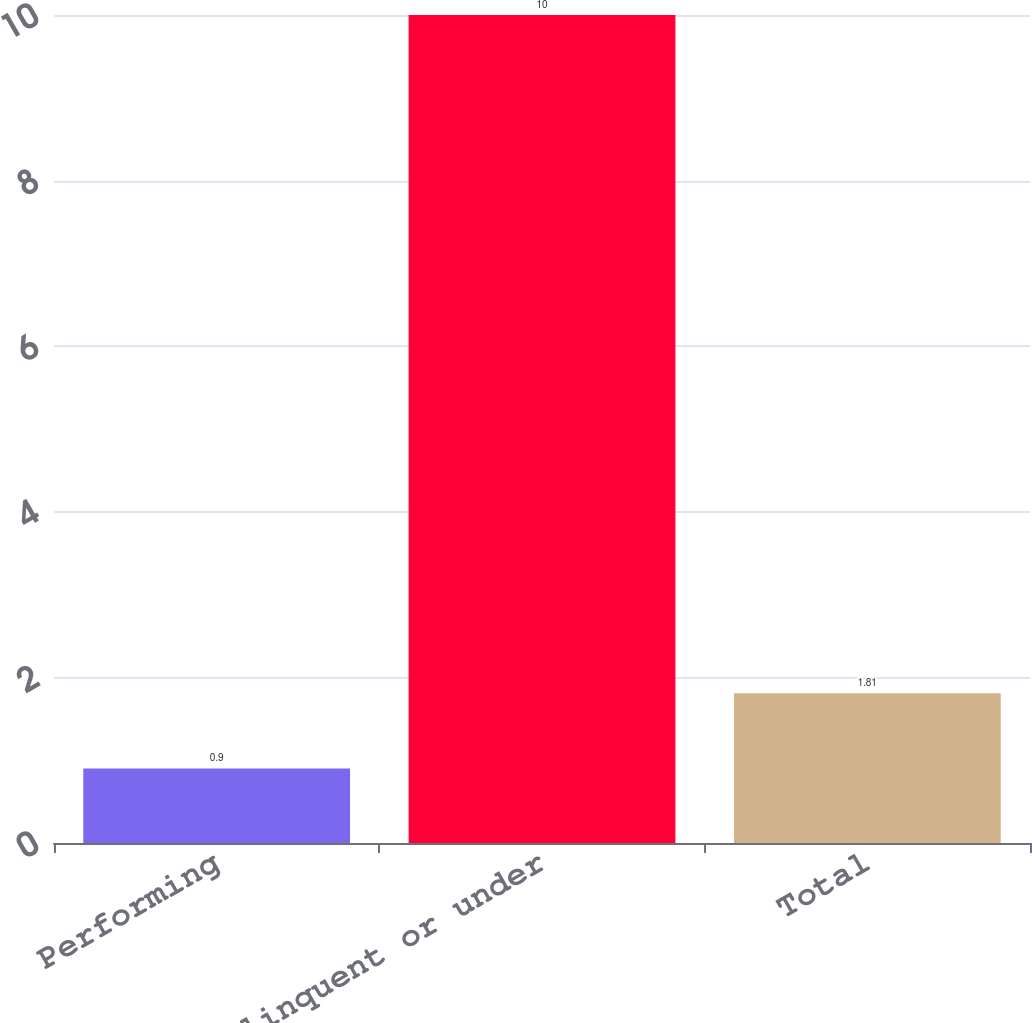Convert chart. <chart><loc_0><loc_0><loc_500><loc_500><bar_chart><fcel>Performing<fcel>Delinquent or under<fcel>Total<nl><fcel>0.9<fcel>10<fcel>1.81<nl></chart> 